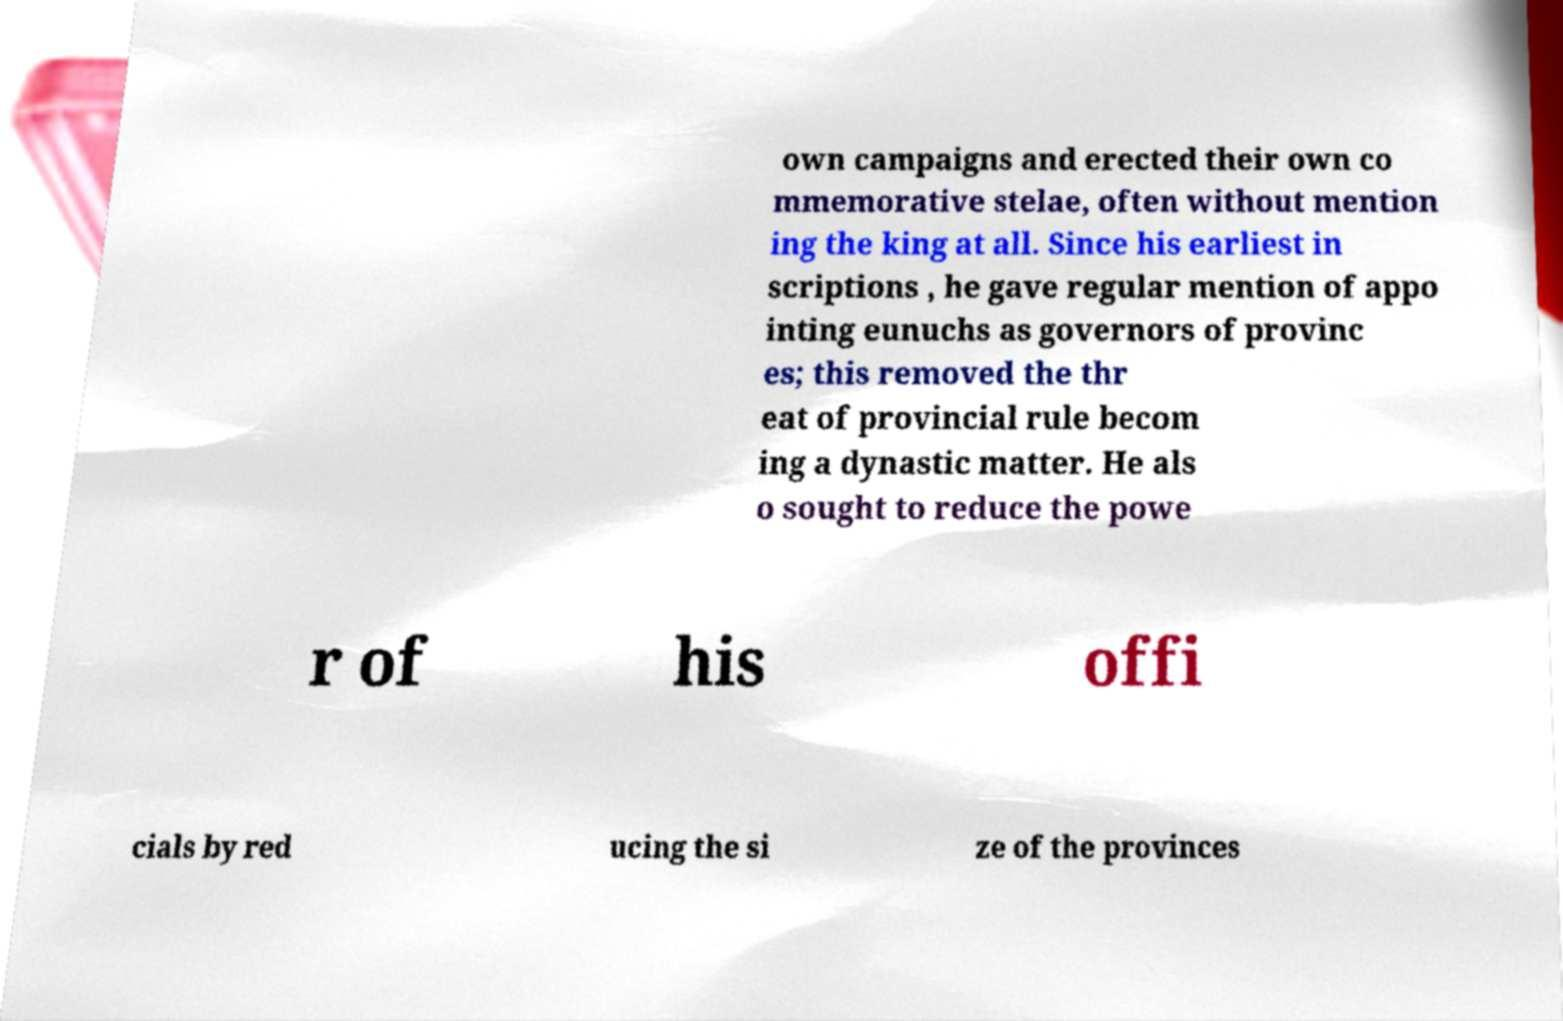Can you accurately transcribe the text from the provided image for me? own campaigns and erected their own co mmemorative stelae, often without mention ing the king at all. Since his earliest in scriptions , he gave regular mention of appo inting eunuchs as governors of provinc es; this removed the thr eat of provincial rule becom ing a dynastic matter. He als o sought to reduce the powe r of his offi cials by red ucing the si ze of the provinces 